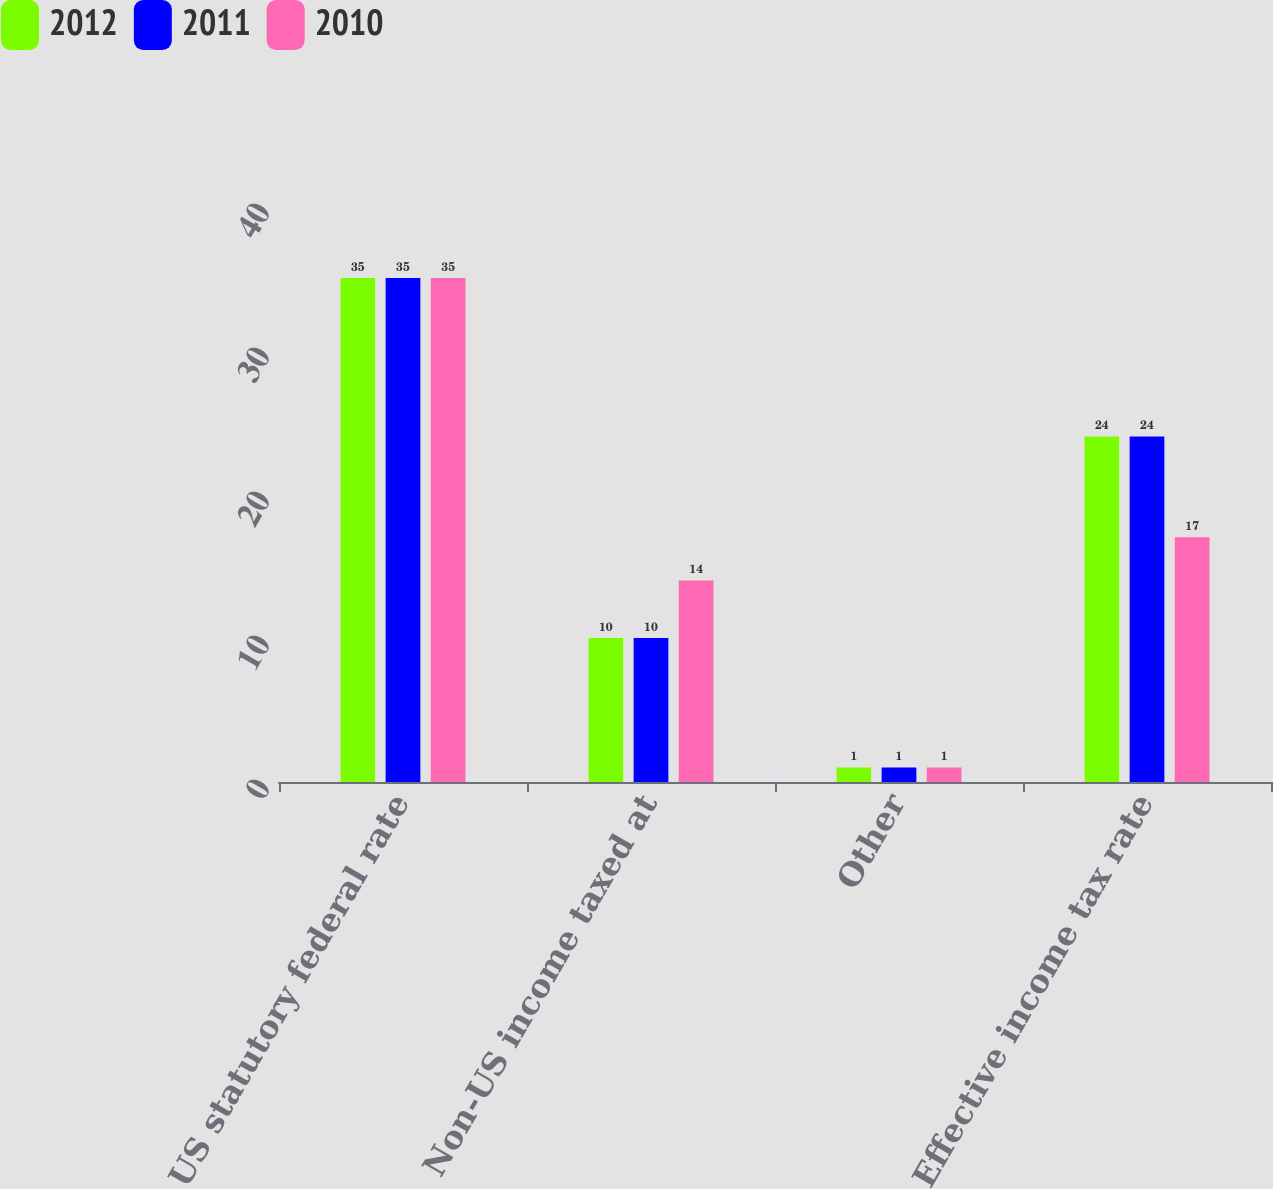Convert chart. <chart><loc_0><loc_0><loc_500><loc_500><stacked_bar_chart><ecel><fcel>US statutory federal rate<fcel>Non-US income taxed at<fcel>Other<fcel>Effective income tax rate<nl><fcel>2012<fcel>35<fcel>10<fcel>1<fcel>24<nl><fcel>2011<fcel>35<fcel>10<fcel>1<fcel>24<nl><fcel>2010<fcel>35<fcel>14<fcel>1<fcel>17<nl></chart> 